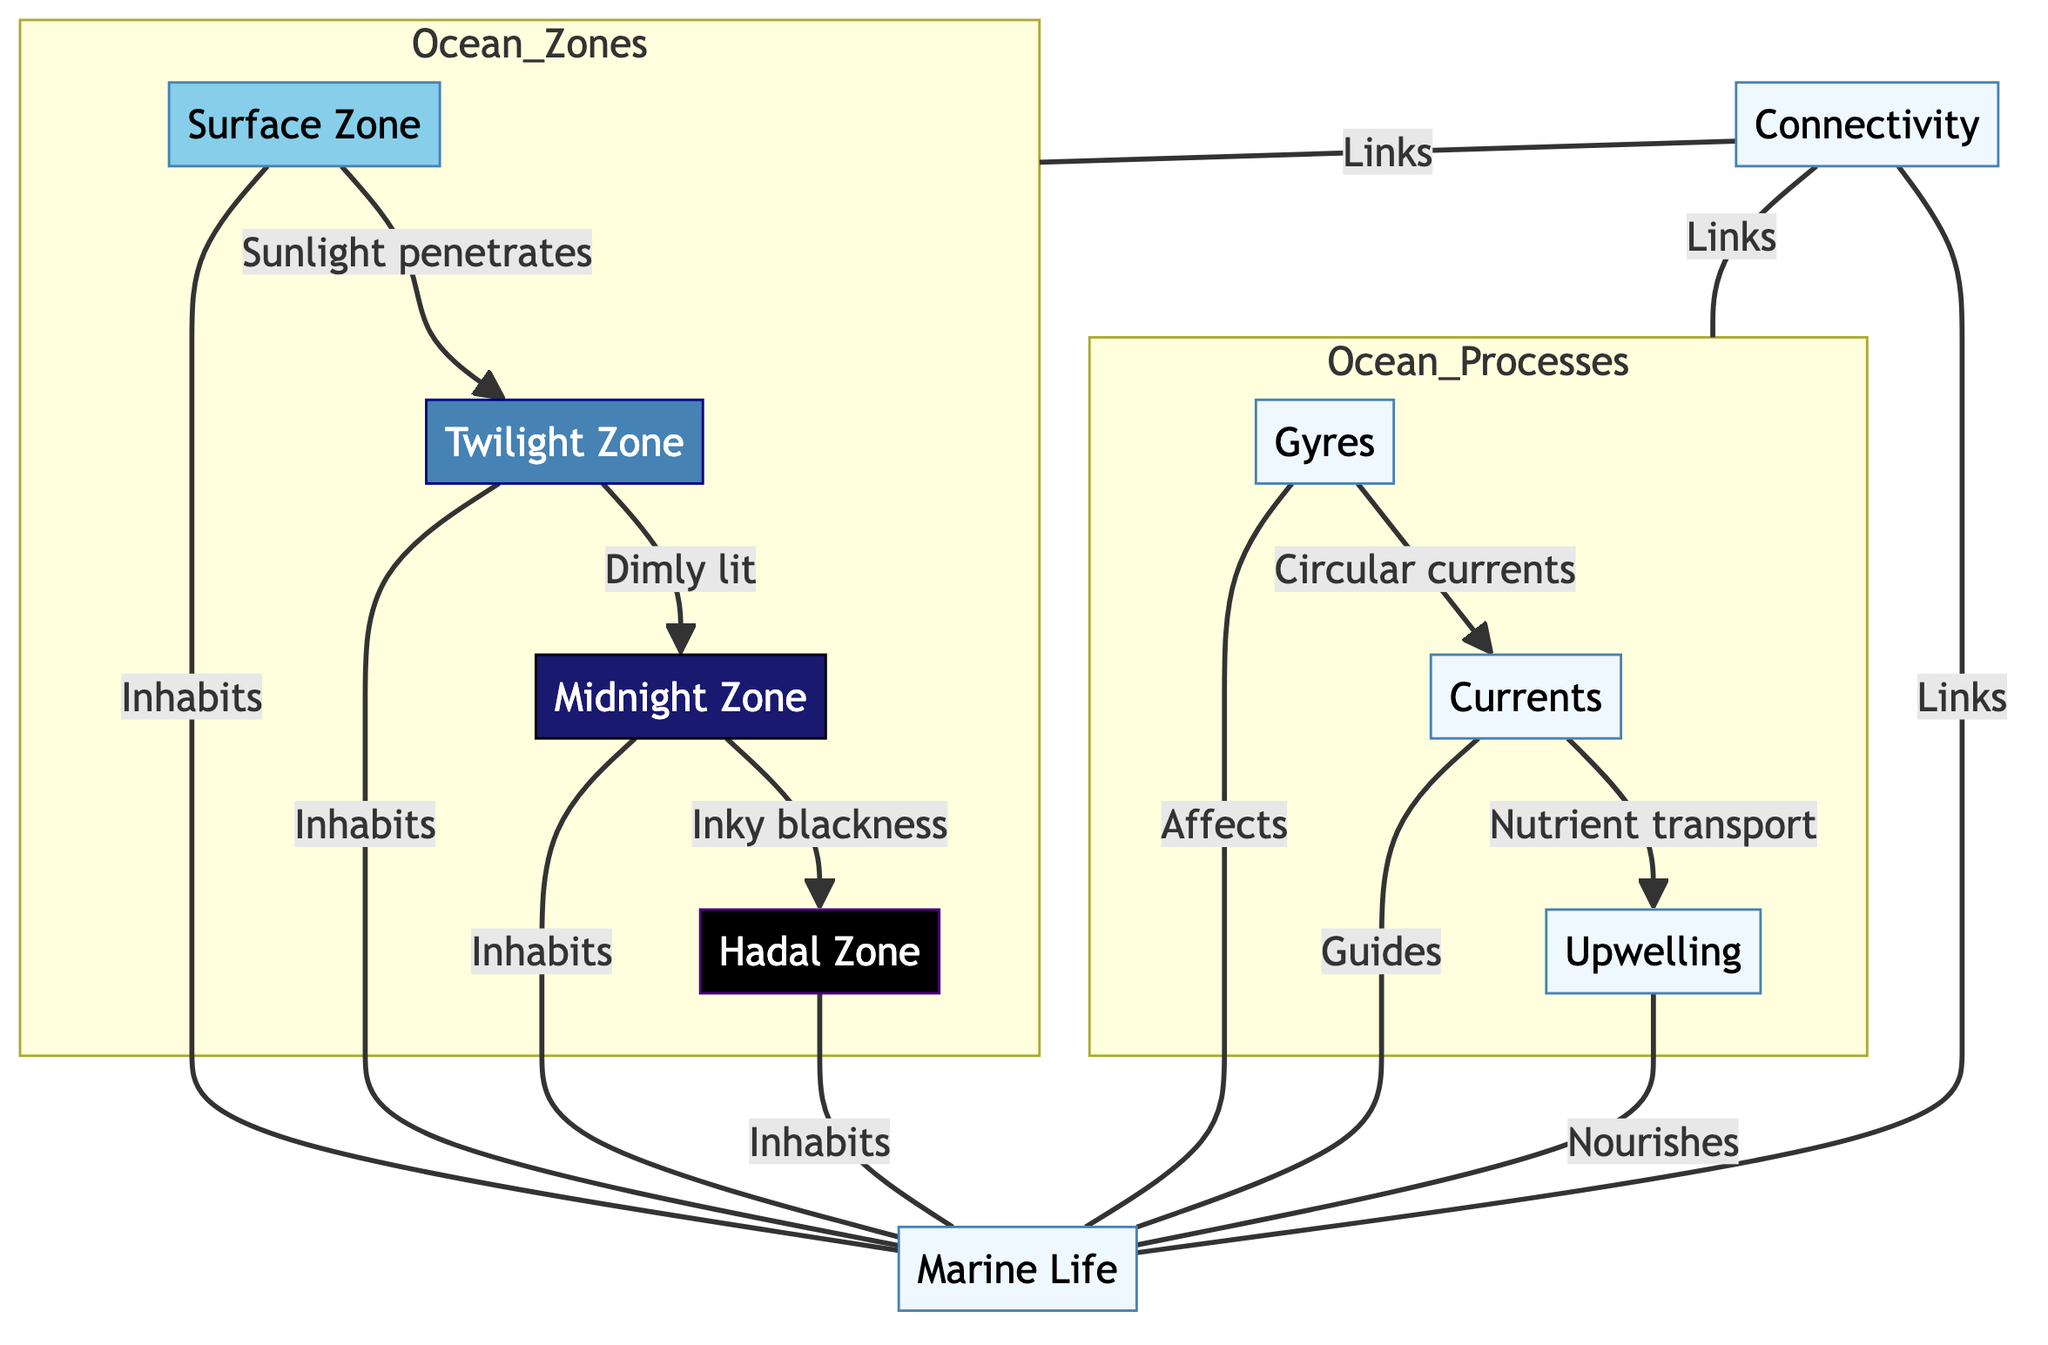What is the first zone in the ocean diagram? The first zone in the ocean diagram is labeled as "Surface Zone," which indicates it is at the top level of the ocean.
Answer: Surface Zone How many ocean zones are depicted in the diagram? The diagram shows four distinct ocean zones: Surface Zone, Twilight Zone, Midnight Zone, and Hadal Zone. Counting them gives a total of four.
Answer: 4 Which ocean zone is characterized by "inky blackness"? The zone characterized by "inky blackness" is labeled as the "Midnight Zone," suggesting it is very dark due to the absence of light.
Answer: Midnight Zone What process is linked with "Nutrient transport"? The process linked with "Nutrient transport" is "Currents," indicating that the movement of water is responsible for distributing nutrients across the ocean.
Answer: Currents Which zones are inhabited by marine life? All four zones—Surface Zone, Twilight Zone, Midnight Zone, and Hadal Zone—are said to be inhabited by marine life, showcasing the diversity of life at different depths.
Answer: All four zones How does "Upwelling" relate to marine life? "Upwelling" is described as a process that "Nourishes" marine life, implying that it is crucial for providing essential nutrients that support biological activity in the ocean.
Answer: Nourishes What do gyres affect in the ocean? The gyres affect "Marine Life," indicating their significant role in influencing the distribution and health of oceanic species.
Answer: Marine Life What is the relationship between ocean zones and ocean processes? The relationship is represented by the concept of "Connectivity," which links ocean zones and ocean processes, demonstrating the interconnected nature of these systems.
Answer: Connectivity Which zone is directly below the Twilight Zone? The zone directly below the Twilight Zone is the Midnight Zone, indicating the progression of depth and light penetration in the ocean.
Answer: Midnight Zone 